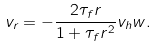Convert formula to latex. <formula><loc_0><loc_0><loc_500><loc_500>v _ { r } = - \frac { 2 \tau _ { f } r } { 1 + \tau _ { f } r ^ { 2 } } v _ { h } w . \label H { e q \colon v r }</formula> 